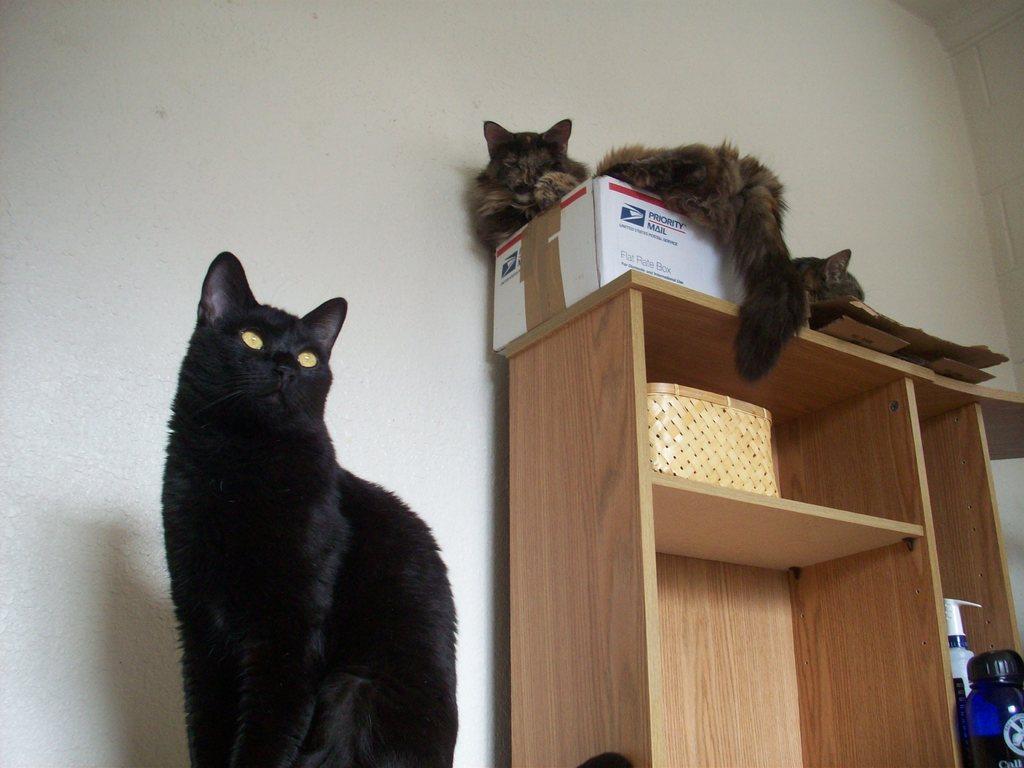How would you summarize this image in a sentence or two? This picture is clicked inside the room. On the left there is a cat sitting on an object. On the right we can see a wooden cabinet containing bottles and a wooden basket and we can see the cat sitting on the top of a box which is placed on the top of the wooden cabinet and we can see another cat seems to be sitting on an object which is placed on the top of the wooden cabinet. In the background we can see the wall and we can see the text on the box. 